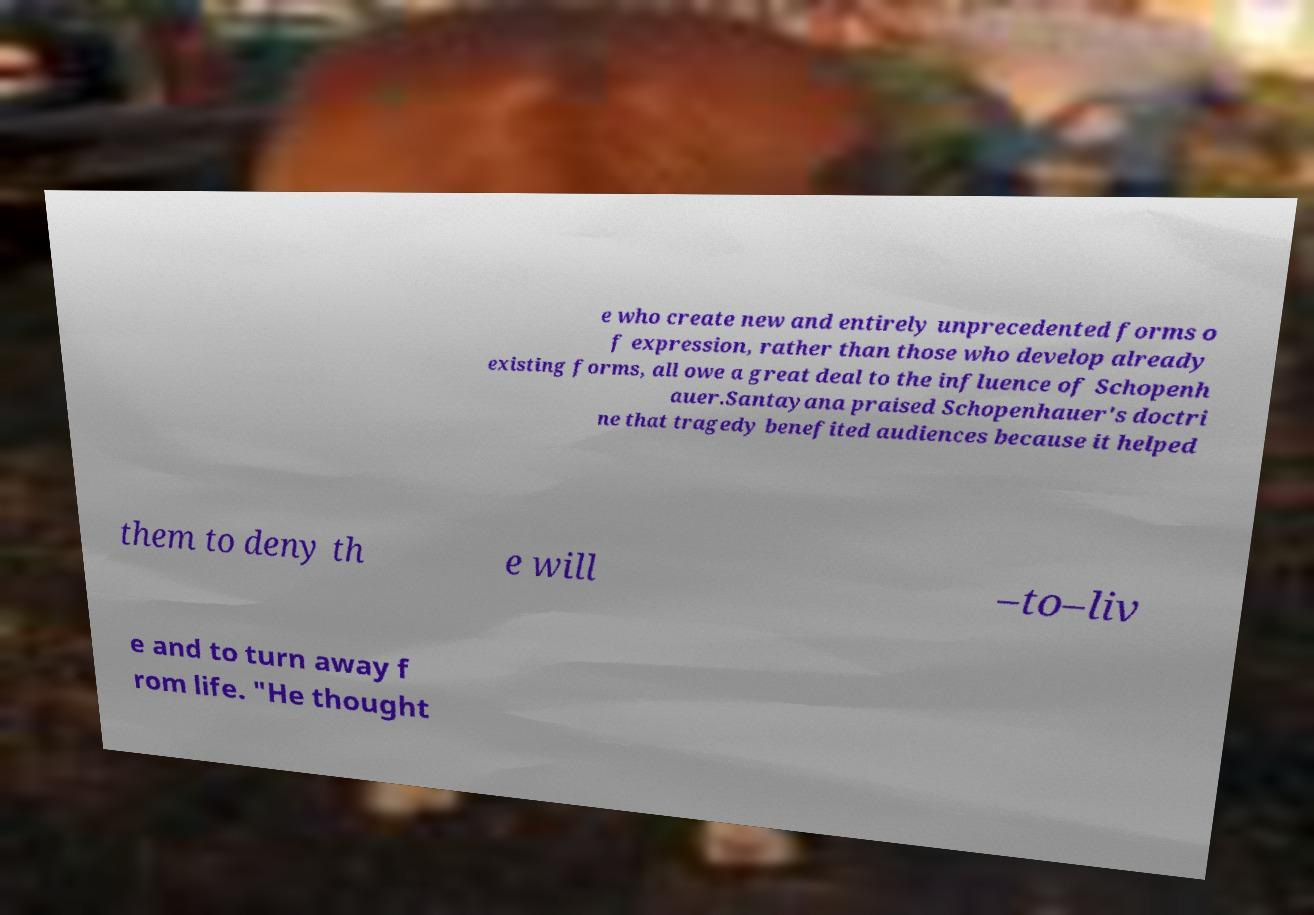What messages or text are displayed in this image? I need them in a readable, typed format. e who create new and entirely unprecedented forms o f expression, rather than those who develop already existing forms, all owe a great deal to the influence of Schopenh auer.Santayana praised Schopenhauer's doctri ne that tragedy benefited audiences because it helped them to deny th e will –to–liv e and to turn away f rom life. "He thought 